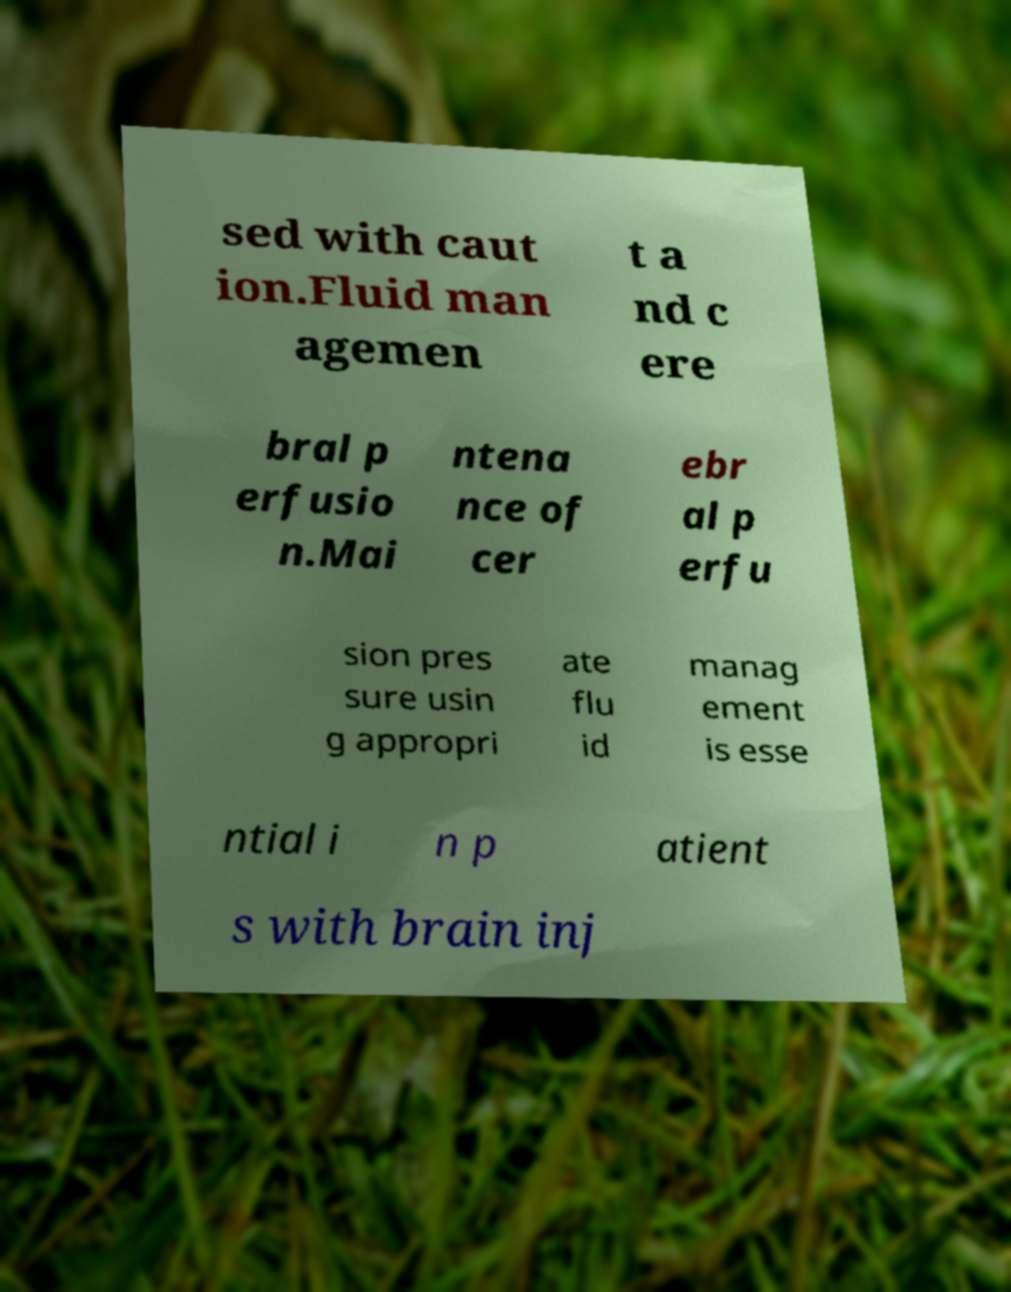Can you accurately transcribe the text from the provided image for me? sed with caut ion.Fluid man agemen t a nd c ere bral p erfusio n.Mai ntena nce of cer ebr al p erfu sion pres sure usin g appropri ate flu id manag ement is esse ntial i n p atient s with brain inj 